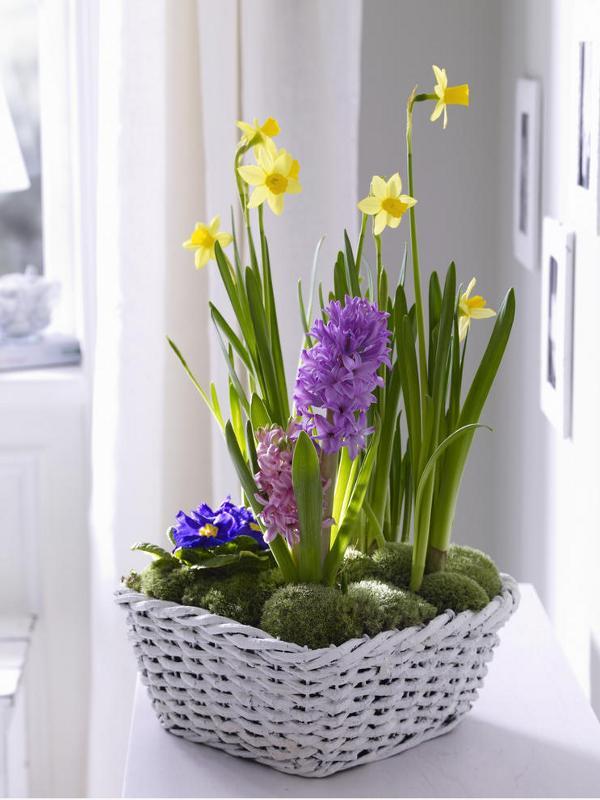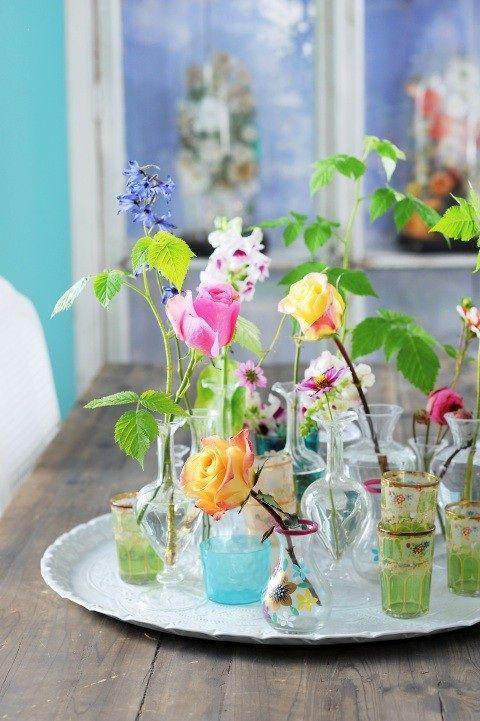The first image is the image on the left, the second image is the image on the right. Considering the images on both sides, is "Purple hyacinth and moss are growing in at least one white planter in the image on the left." valid? Answer yes or no. Yes. The first image is the image on the left, the second image is the image on the right. Analyze the images presented: Is the assertion "Right image features a variety of flowers, including roses." valid? Answer yes or no. Yes. 